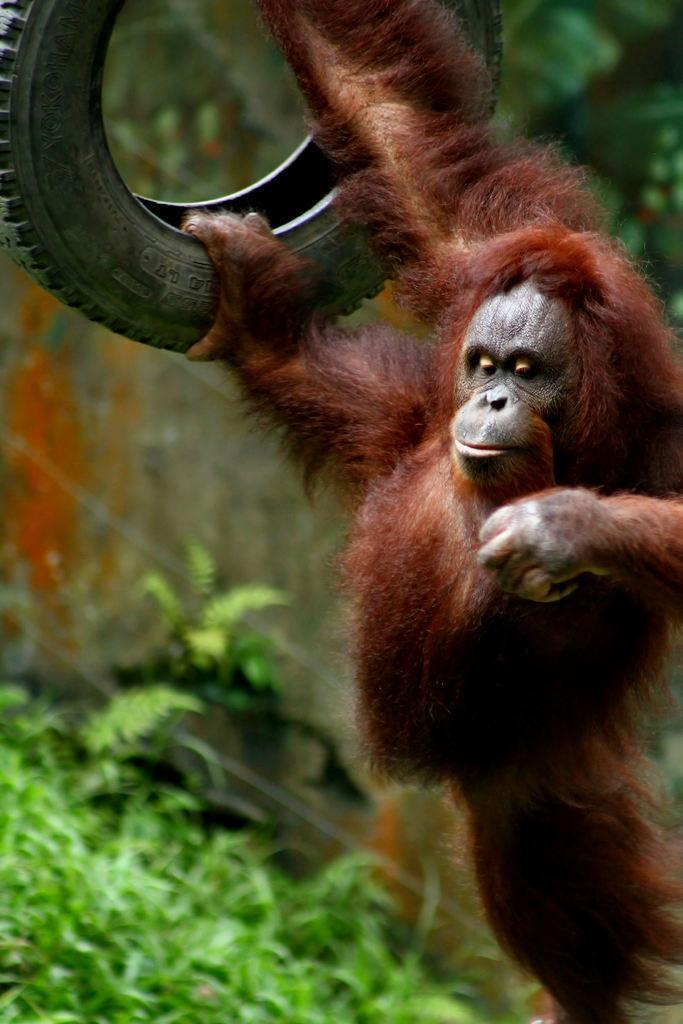In one or two sentences, can you explain what this image depicts? In this image I can see an animal is holding a tire in hand. In the background I can see plants, trees and a fence. This image is taken may be during a day. 